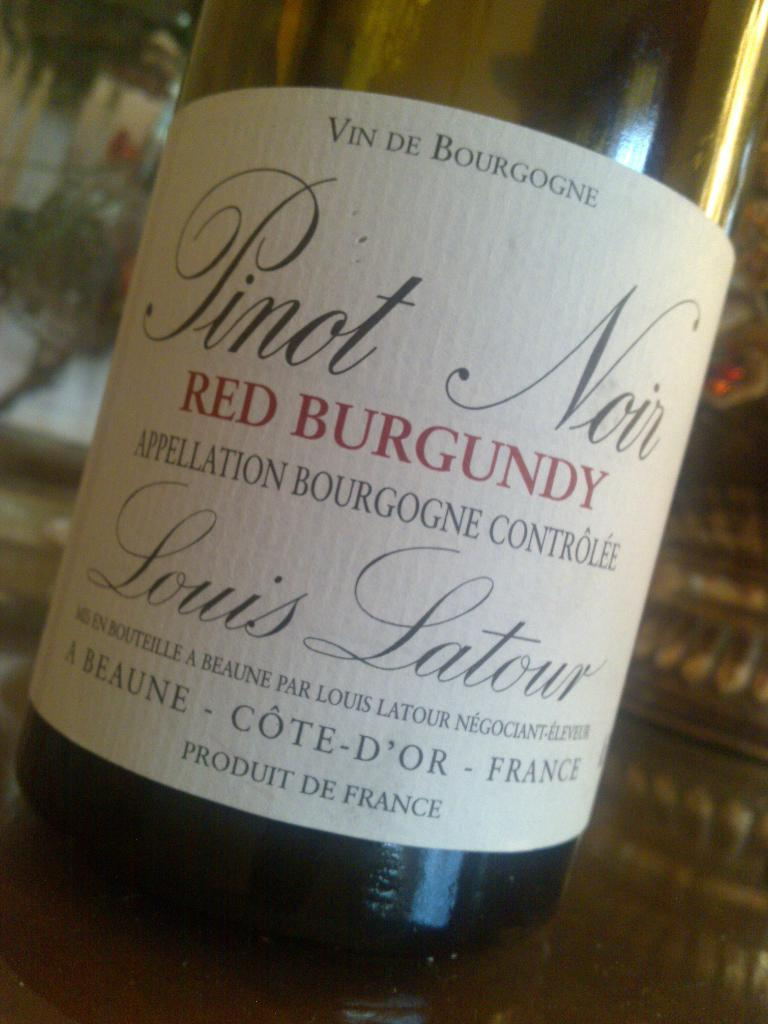<image>
Write a terse but informative summary of the picture. a Red Burgundy wine has many words on it 